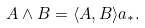Convert formula to latex. <formula><loc_0><loc_0><loc_500><loc_500>A \wedge B = \langle A , B \rangle a _ { * } .</formula> 